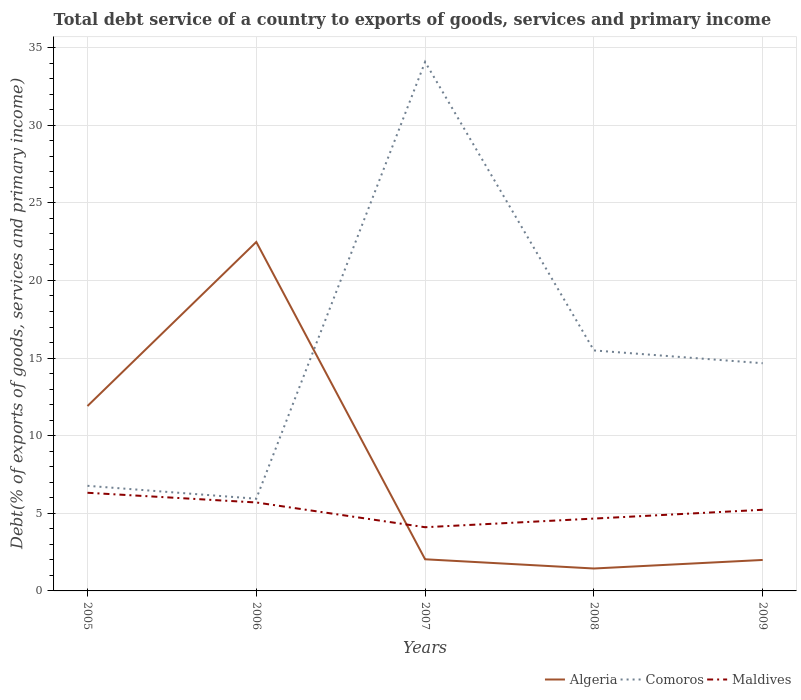How many different coloured lines are there?
Offer a terse response. 3. Is the number of lines equal to the number of legend labels?
Make the answer very short. Yes. Across all years, what is the maximum total debt service in Comoros?
Your answer should be very brief. 5.94. What is the total total debt service in Comoros in the graph?
Your answer should be very brief. -27.31. What is the difference between the highest and the second highest total debt service in Algeria?
Provide a succinct answer. 21.03. Is the total debt service in Maldives strictly greater than the total debt service in Algeria over the years?
Provide a short and direct response. No. How many lines are there?
Your answer should be very brief. 3. How many years are there in the graph?
Make the answer very short. 5. What is the difference between two consecutive major ticks on the Y-axis?
Your answer should be very brief. 5. Are the values on the major ticks of Y-axis written in scientific E-notation?
Keep it short and to the point. No. How are the legend labels stacked?
Your answer should be very brief. Horizontal. What is the title of the graph?
Give a very brief answer. Total debt service of a country to exports of goods, services and primary income. What is the label or title of the X-axis?
Ensure brevity in your answer.  Years. What is the label or title of the Y-axis?
Your answer should be very brief. Debt(% of exports of goods, services and primary income). What is the Debt(% of exports of goods, services and primary income) of Algeria in 2005?
Your answer should be very brief. 11.91. What is the Debt(% of exports of goods, services and primary income) in Comoros in 2005?
Your response must be concise. 6.77. What is the Debt(% of exports of goods, services and primary income) in Maldives in 2005?
Offer a terse response. 6.32. What is the Debt(% of exports of goods, services and primary income) in Algeria in 2006?
Your response must be concise. 22.48. What is the Debt(% of exports of goods, services and primary income) of Comoros in 2006?
Your answer should be very brief. 5.94. What is the Debt(% of exports of goods, services and primary income) in Maldives in 2006?
Make the answer very short. 5.7. What is the Debt(% of exports of goods, services and primary income) in Algeria in 2007?
Your answer should be very brief. 2.04. What is the Debt(% of exports of goods, services and primary income) in Comoros in 2007?
Your answer should be compact. 34.08. What is the Debt(% of exports of goods, services and primary income) of Maldives in 2007?
Keep it short and to the point. 4.1. What is the Debt(% of exports of goods, services and primary income) of Algeria in 2008?
Make the answer very short. 1.44. What is the Debt(% of exports of goods, services and primary income) in Comoros in 2008?
Your answer should be very brief. 15.49. What is the Debt(% of exports of goods, services and primary income) of Maldives in 2008?
Provide a succinct answer. 4.66. What is the Debt(% of exports of goods, services and primary income) of Algeria in 2009?
Provide a succinct answer. 2. What is the Debt(% of exports of goods, services and primary income) of Comoros in 2009?
Your answer should be compact. 14.67. What is the Debt(% of exports of goods, services and primary income) of Maldives in 2009?
Your response must be concise. 5.23. Across all years, what is the maximum Debt(% of exports of goods, services and primary income) in Algeria?
Provide a short and direct response. 22.48. Across all years, what is the maximum Debt(% of exports of goods, services and primary income) of Comoros?
Offer a very short reply. 34.08. Across all years, what is the maximum Debt(% of exports of goods, services and primary income) of Maldives?
Keep it short and to the point. 6.32. Across all years, what is the minimum Debt(% of exports of goods, services and primary income) in Algeria?
Provide a short and direct response. 1.44. Across all years, what is the minimum Debt(% of exports of goods, services and primary income) in Comoros?
Offer a very short reply. 5.94. Across all years, what is the minimum Debt(% of exports of goods, services and primary income) of Maldives?
Keep it short and to the point. 4.1. What is the total Debt(% of exports of goods, services and primary income) in Algeria in the graph?
Provide a short and direct response. 39.87. What is the total Debt(% of exports of goods, services and primary income) in Comoros in the graph?
Provide a succinct answer. 76.95. What is the total Debt(% of exports of goods, services and primary income) in Maldives in the graph?
Ensure brevity in your answer.  26.01. What is the difference between the Debt(% of exports of goods, services and primary income) in Algeria in 2005 and that in 2006?
Ensure brevity in your answer.  -10.57. What is the difference between the Debt(% of exports of goods, services and primary income) of Comoros in 2005 and that in 2006?
Your response must be concise. 0.83. What is the difference between the Debt(% of exports of goods, services and primary income) of Maldives in 2005 and that in 2006?
Provide a short and direct response. 0.63. What is the difference between the Debt(% of exports of goods, services and primary income) of Algeria in 2005 and that in 2007?
Keep it short and to the point. 9.87. What is the difference between the Debt(% of exports of goods, services and primary income) in Comoros in 2005 and that in 2007?
Make the answer very short. -27.31. What is the difference between the Debt(% of exports of goods, services and primary income) of Maldives in 2005 and that in 2007?
Provide a succinct answer. 2.22. What is the difference between the Debt(% of exports of goods, services and primary income) of Algeria in 2005 and that in 2008?
Your response must be concise. 10.47. What is the difference between the Debt(% of exports of goods, services and primary income) of Comoros in 2005 and that in 2008?
Your answer should be compact. -8.72. What is the difference between the Debt(% of exports of goods, services and primary income) in Maldives in 2005 and that in 2008?
Keep it short and to the point. 1.66. What is the difference between the Debt(% of exports of goods, services and primary income) of Algeria in 2005 and that in 2009?
Your answer should be very brief. 9.91. What is the difference between the Debt(% of exports of goods, services and primary income) of Comoros in 2005 and that in 2009?
Your answer should be compact. -7.9. What is the difference between the Debt(% of exports of goods, services and primary income) in Maldives in 2005 and that in 2009?
Give a very brief answer. 1.09. What is the difference between the Debt(% of exports of goods, services and primary income) in Algeria in 2006 and that in 2007?
Make the answer very short. 20.44. What is the difference between the Debt(% of exports of goods, services and primary income) in Comoros in 2006 and that in 2007?
Make the answer very short. -28.14. What is the difference between the Debt(% of exports of goods, services and primary income) of Maldives in 2006 and that in 2007?
Your answer should be very brief. 1.59. What is the difference between the Debt(% of exports of goods, services and primary income) of Algeria in 2006 and that in 2008?
Keep it short and to the point. 21.04. What is the difference between the Debt(% of exports of goods, services and primary income) in Comoros in 2006 and that in 2008?
Make the answer very short. -9.55. What is the difference between the Debt(% of exports of goods, services and primary income) of Algeria in 2006 and that in 2009?
Keep it short and to the point. 20.48. What is the difference between the Debt(% of exports of goods, services and primary income) of Comoros in 2006 and that in 2009?
Ensure brevity in your answer.  -8.73. What is the difference between the Debt(% of exports of goods, services and primary income) of Maldives in 2006 and that in 2009?
Your answer should be compact. 0.47. What is the difference between the Debt(% of exports of goods, services and primary income) in Algeria in 2007 and that in 2008?
Keep it short and to the point. 0.59. What is the difference between the Debt(% of exports of goods, services and primary income) in Comoros in 2007 and that in 2008?
Offer a very short reply. 18.59. What is the difference between the Debt(% of exports of goods, services and primary income) in Maldives in 2007 and that in 2008?
Your answer should be compact. -0.56. What is the difference between the Debt(% of exports of goods, services and primary income) of Algeria in 2007 and that in 2009?
Give a very brief answer. 0.04. What is the difference between the Debt(% of exports of goods, services and primary income) in Comoros in 2007 and that in 2009?
Offer a terse response. 19.41. What is the difference between the Debt(% of exports of goods, services and primary income) of Maldives in 2007 and that in 2009?
Your answer should be compact. -1.12. What is the difference between the Debt(% of exports of goods, services and primary income) of Algeria in 2008 and that in 2009?
Offer a very short reply. -0.55. What is the difference between the Debt(% of exports of goods, services and primary income) in Comoros in 2008 and that in 2009?
Ensure brevity in your answer.  0.82. What is the difference between the Debt(% of exports of goods, services and primary income) of Maldives in 2008 and that in 2009?
Give a very brief answer. -0.57. What is the difference between the Debt(% of exports of goods, services and primary income) of Algeria in 2005 and the Debt(% of exports of goods, services and primary income) of Comoros in 2006?
Provide a succinct answer. 5.97. What is the difference between the Debt(% of exports of goods, services and primary income) of Algeria in 2005 and the Debt(% of exports of goods, services and primary income) of Maldives in 2006?
Provide a short and direct response. 6.21. What is the difference between the Debt(% of exports of goods, services and primary income) in Comoros in 2005 and the Debt(% of exports of goods, services and primary income) in Maldives in 2006?
Ensure brevity in your answer.  1.07. What is the difference between the Debt(% of exports of goods, services and primary income) of Algeria in 2005 and the Debt(% of exports of goods, services and primary income) of Comoros in 2007?
Keep it short and to the point. -22.17. What is the difference between the Debt(% of exports of goods, services and primary income) in Algeria in 2005 and the Debt(% of exports of goods, services and primary income) in Maldives in 2007?
Offer a terse response. 7.81. What is the difference between the Debt(% of exports of goods, services and primary income) of Comoros in 2005 and the Debt(% of exports of goods, services and primary income) of Maldives in 2007?
Provide a succinct answer. 2.67. What is the difference between the Debt(% of exports of goods, services and primary income) in Algeria in 2005 and the Debt(% of exports of goods, services and primary income) in Comoros in 2008?
Make the answer very short. -3.58. What is the difference between the Debt(% of exports of goods, services and primary income) of Algeria in 2005 and the Debt(% of exports of goods, services and primary income) of Maldives in 2008?
Your answer should be compact. 7.25. What is the difference between the Debt(% of exports of goods, services and primary income) of Comoros in 2005 and the Debt(% of exports of goods, services and primary income) of Maldives in 2008?
Your response must be concise. 2.11. What is the difference between the Debt(% of exports of goods, services and primary income) in Algeria in 2005 and the Debt(% of exports of goods, services and primary income) in Comoros in 2009?
Make the answer very short. -2.76. What is the difference between the Debt(% of exports of goods, services and primary income) in Algeria in 2005 and the Debt(% of exports of goods, services and primary income) in Maldives in 2009?
Your answer should be very brief. 6.68. What is the difference between the Debt(% of exports of goods, services and primary income) in Comoros in 2005 and the Debt(% of exports of goods, services and primary income) in Maldives in 2009?
Provide a short and direct response. 1.54. What is the difference between the Debt(% of exports of goods, services and primary income) of Algeria in 2006 and the Debt(% of exports of goods, services and primary income) of Comoros in 2007?
Keep it short and to the point. -11.6. What is the difference between the Debt(% of exports of goods, services and primary income) of Algeria in 2006 and the Debt(% of exports of goods, services and primary income) of Maldives in 2007?
Your answer should be very brief. 18.38. What is the difference between the Debt(% of exports of goods, services and primary income) of Comoros in 2006 and the Debt(% of exports of goods, services and primary income) of Maldives in 2007?
Your answer should be very brief. 1.84. What is the difference between the Debt(% of exports of goods, services and primary income) in Algeria in 2006 and the Debt(% of exports of goods, services and primary income) in Comoros in 2008?
Your answer should be very brief. 6.99. What is the difference between the Debt(% of exports of goods, services and primary income) in Algeria in 2006 and the Debt(% of exports of goods, services and primary income) in Maldives in 2008?
Provide a short and direct response. 17.82. What is the difference between the Debt(% of exports of goods, services and primary income) of Comoros in 2006 and the Debt(% of exports of goods, services and primary income) of Maldives in 2008?
Keep it short and to the point. 1.28. What is the difference between the Debt(% of exports of goods, services and primary income) in Algeria in 2006 and the Debt(% of exports of goods, services and primary income) in Comoros in 2009?
Your response must be concise. 7.81. What is the difference between the Debt(% of exports of goods, services and primary income) of Algeria in 2006 and the Debt(% of exports of goods, services and primary income) of Maldives in 2009?
Offer a very short reply. 17.25. What is the difference between the Debt(% of exports of goods, services and primary income) of Comoros in 2006 and the Debt(% of exports of goods, services and primary income) of Maldives in 2009?
Offer a very short reply. 0.71. What is the difference between the Debt(% of exports of goods, services and primary income) in Algeria in 2007 and the Debt(% of exports of goods, services and primary income) in Comoros in 2008?
Provide a short and direct response. -13.45. What is the difference between the Debt(% of exports of goods, services and primary income) in Algeria in 2007 and the Debt(% of exports of goods, services and primary income) in Maldives in 2008?
Ensure brevity in your answer.  -2.62. What is the difference between the Debt(% of exports of goods, services and primary income) in Comoros in 2007 and the Debt(% of exports of goods, services and primary income) in Maldives in 2008?
Ensure brevity in your answer.  29.42. What is the difference between the Debt(% of exports of goods, services and primary income) in Algeria in 2007 and the Debt(% of exports of goods, services and primary income) in Comoros in 2009?
Your answer should be compact. -12.63. What is the difference between the Debt(% of exports of goods, services and primary income) of Algeria in 2007 and the Debt(% of exports of goods, services and primary income) of Maldives in 2009?
Offer a very short reply. -3.19. What is the difference between the Debt(% of exports of goods, services and primary income) in Comoros in 2007 and the Debt(% of exports of goods, services and primary income) in Maldives in 2009?
Ensure brevity in your answer.  28.85. What is the difference between the Debt(% of exports of goods, services and primary income) in Algeria in 2008 and the Debt(% of exports of goods, services and primary income) in Comoros in 2009?
Keep it short and to the point. -13.22. What is the difference between the Debt(% of exports of goods, services and primary income) of Algeria in 2008 and the Debt(% of exports of goods, services and primary income) of Maldives in 2009?
Your response must be concise. -3.78. What is the difference between the Debt(% of exports of goods, services and primary income) in Comoros in 2008 and the Debt(% of exports of goods, services and primary income) in Maldives in 2009?
Your answer should be very brief. 10.26. What is the average Debt(% of exports of goods, services and primary income) in Algeria per year?
Give a very brief answer. 7.97. What is the average Debt(% of exports of goods, services and primary income) in Comoros per year?
Offer a very short reply. 15.39. What is the average Debt(% of exports of goods, services and primary income) of Maldives per year?
Ensure brevity in your answer.  5.2. In the year 2005, what is the difference between the Debt(% of exports of goods, services and primary income) in Algeria and Debt(% of exports of goods, services and primary income) in Comoros?
Offer a very short reply. 5.14. In the year 2005, what is the difference between the Debt(% of exports of goods, services and primary income) of Algeria and Debt(% of exports of goods, services and primary income) of Maldives?
Provide a succinct answer. 5.59. In the year 2005, what is the difference between the Debt(% of exports of goods, services and primary income) of Comoros and Debt(% of exports of goods, services and primary income) of Maldives?
Your response must be concise. 0.45. In the year 2006, what is the difference between the Debt(% of exports of goods, services and primary income) in Algeria and Debt(% of exports of goods, services and primary income) in Comoros?
Ensure brevity in your answer.  16.54. In the year 2006, what is the difference between the Debt(% of exports of goods, services and primary income) of Algeria and Debt(% of exports of goods, services and primary income) of Maldives?
Offer a terse response. 16.78. In the year 2006, what is the difference between the Debt(% of exports of goods, services and primary income) in Comoros and Debt(% of exports of goods, services and primary income) in Maldives?
Make the answer very short. 0.24. In the year 2007, what is the difference between the Debt(% of exports of goods, services and primary income) of Algeria and Debt(% of exports of goods, services and primary income) of Comoros?
Offer a terse response. -32.04. In the year 2007, what is the difference between the Debt(% of exports of goods, services and primary income) in Algeria and Debt(% of exports of goods, services and primary income) in Maldives?
Give a very brief answer. -2.06. In the year 2007, what is the difference between the Debt(% of exports of goods, services and primary income) in Comoros and Debt(% of exports of goods, services and primary income) in Maldives?
Make the answer very short. 29.98. In the year 2008, what is the difference between the Debt(% of exports of goods, services and primary income) in Algeria and Debt(% of exports of goods, services and primary income) in Comoros?
Give a very brief answer. -14.05. In the year 2008, what is the difference between the Debt(% of exports of goods, services and primary income) of Algeria and Debt(% of exports of goods, services and primary income) of Maldives?
Your answer should be compact. -3.22. In the year 2008, what is the difference between the Debt(% of exports of goods, services and primary income) in Comoros and Debt(% of exports of goods, services and primary income) in Maldives?
Ensure brevity in your answer.  10.83. In the year 2009, what is the difference between the Debt(% of exports of goods, services and primary income) of Algeria and Debt(% of exports of goods, services and primary income) of Comoros?
Provide a succinct answer. -12.67. In the year 2009, what is the difference between the Debt(% of exports of goods, services and primary income) of Algeria and Debt(% of exports of goods, services and primary income) of Maldives?
Offer a very short reply. -3.23. In the year 2009, what is the difference between the Debt(% of exports of goods, services and primary income) in Comoros and Debt(% of exports of goods, services and primary income) in Maldives?
Give a very brief answer. 9.44. What is the ratio of the Debt(% of exports of goods, services and primary income) of Algeria in 2005 to that in 2006?
Offer a very short reply. 0.53. What is the ratio of the Debt(% of exports of goods, services and primary income) of Comoros in 2005 to that in 2006?
Offer a very short reply. 1.14. What is the ratio of the Debt(% of exports of goods, services and primary income) in Maldives in 2005 to that in 2006?
Your response must be concise. 1.11. What is the ratio of the Debt(% of exports of goods, services and primary income) in Algeria in 2005 to that in 2007?
Keep it short and to the point. 5.84. What is the ratio of the Debt(% of exports of goods, services and primary income) in Comoros in 2005 to that in 2007?
Ensure brevity in your answer.  0.2. What is the ratio of the Debt(% of exports of goods, services and primary income) in Maldives in 2005 to that in 2007?
Your answer should be compact. 1.54. What is the ratio of the Debt(% of exports of goods, services and primary income) of Algeria in 2005 to that in 2008?
Offer a very short reply. 8.25. What is the ratio of the Debt(% of exports of goods, services and primary income) in Comoros in 2005 to that in 2008?
Keep it short and to the point. 0.44. What is the ratio of the Debt(% of exports of goods, services and primary income) in Maldives in 2005 to that in 2008?
Provide a succinct answer. 1.36. What is the ratio of the Debt(% of exports of goods, services and primary income) in Algeria in 2005 to that in 2009?
Keep it short and to the point. 5.97. What is the ratio of the Debt(% of exports of goods, services and primary income) of Comoros in 2005 to that in 2009?
Offer a very short reply. 0.46. What is the ratio of the Debt(% of exports of goods, services and primary income) of Maldives in 2005 to that in 2009?
Your answer should be compact. 1.21. What is the ratio of the Debt(% of exports of goods, services and primary income) of Algeria in 2006 to that in 2007?
Offer a very short reply. 11.03. What is the ratio of the Debt(% of exports of goods, services and primary income) of Comoros in 2006 to that in 2007?
Offer a terse response. 0.17. What is the ratio of the Debt(% of exports of goods, services and primary income) in Maldives in 2006 to that in 2007?
Offer a very short reply. 1.39. What is the ratio of the Debt(% of exports of goods, services and primary income) of Algeria in 2006 to that in 2008?
Provide a short and direct response. 15.56. What is the ratio of the Debt(% of exports of goods, services and primary income) in Comoros in 2006 to that in 2008?
Your answer should be compact. 0.38. What is the ratio of the Debt(% of exports of goods, services and primary income) of Maldives in 2006 to that in 2008?
Offer a very short reply. 1.22. What is the ratio of the Debt(% of exports of goods, services and primary income) of Algeria in 2006 to that in 2009?
Provide a succinct answer. 11.27. What is the ratio of the Debt(% of exports of goods, services and primary income) in Comoros in 2006 to that in 2009?
Give a very brief answer. 0.4. What is the ratio of the Debt(% of exports of goods, services and primary income) in Maldives in 2006 to that in 2009?
Keep it short and to the point. 1.09. What is the ratio of the Debt(% of exports of goods, services and primary income) in Algeria in 2007 to that in 2008?
Your response must be concise. 1.41. What is the ratio of the Debt(% of exports of goods, services and primary income) of Comoros in 2007 to that in 2008?
Keep it short and to the point. 2.2. What is the ratio of the Debt(% of exports of goods, services and primary income) of Maldives in 2007 to that in 2008?
Offer a terse response. 0.88. What is the ratio of the Debt(% of exports of goods, services and primary income) of Algeria in 2007 to that in 2009?
Keep it short and to the point. 1.02. What is the ratio of the Debt(% of exports of goods, services and primary income) of Comoros in 2007 to that in 2009?
Keep it short and to the point. 2.32. What is the ratio of the Debt(% of exports of goods, services and primary income) of Maldives in 2007 to that in 2009?
Provide a short and direct response. 0.78. What is the ratio of the Debt(% of exports of goods, services and primary income) in Algeria in 2008 to that in 2009?
Give a very brief answer. 0.72. What is the ratio of the Debt(% of exports of goods, services and primary income) in Comoros in 2008 to that in 2009?
Ensure brevity in your answer.  1.06. What is the ratio of the Debt(% of exports of goods, services and primary income) in Maldives in 2008 to that in 2009?
Your response must be concise. 0.89. What is the difference between the highest and the second highest Debt(% of exports of goods, services and primary income) in Algeria?
Make the answer very short. 10.57. What is the difference between the highest and the second highest Debt(% of exports of goods, services and primary income) of Comoros?
Provide a short and direct response. 18.59. What is the difference between the highest and the second highest Debt(% of exports of goods, services and primary income) in Maldives?
Keep it short and to the point. 0.63. What is the difference between the highest and the lowest Debt(% of exports of goods, services and primary income) in Algeria?
Give a very brief answer. 21.04. What is the difference between the highest and the lowest Debt(% of exports of goods, services and primary income) of Comoros?
Keep it short and to the point. 28.14. What is the difference between the highest and the lowest Debt(% of exports of goods, services and primary income) in Maldives?
Ensure brevity in your answer.  2.22. 